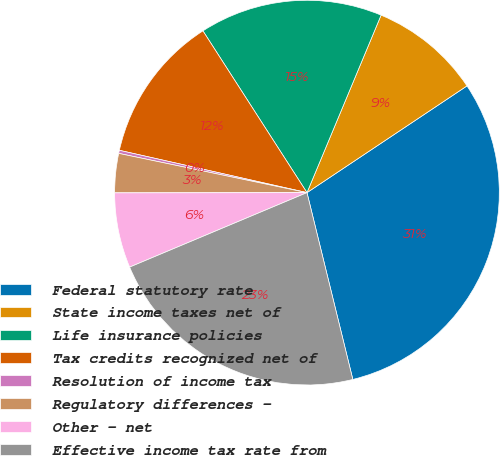Convert chart. <chart><loc_0><loc_0><loc_500><loc_500><pie_chart><fcel>Federal statutory rate<fcel>State income taxes net of<fcel>Life insurance policies<fcel>Tax credits recognized net of<fcel>Resolution of income tax<fcel>Regulatory differences -<fcel>Other - net<fcel>Effective income tax rate from<nl><fcel>30.53%<fcel>9.34%<fcel>15.39%<fcel>12.37%<fcel>0.26%<fcel>3.29%<fcel>6.31%<fcel>22.5%<nl></chart> 